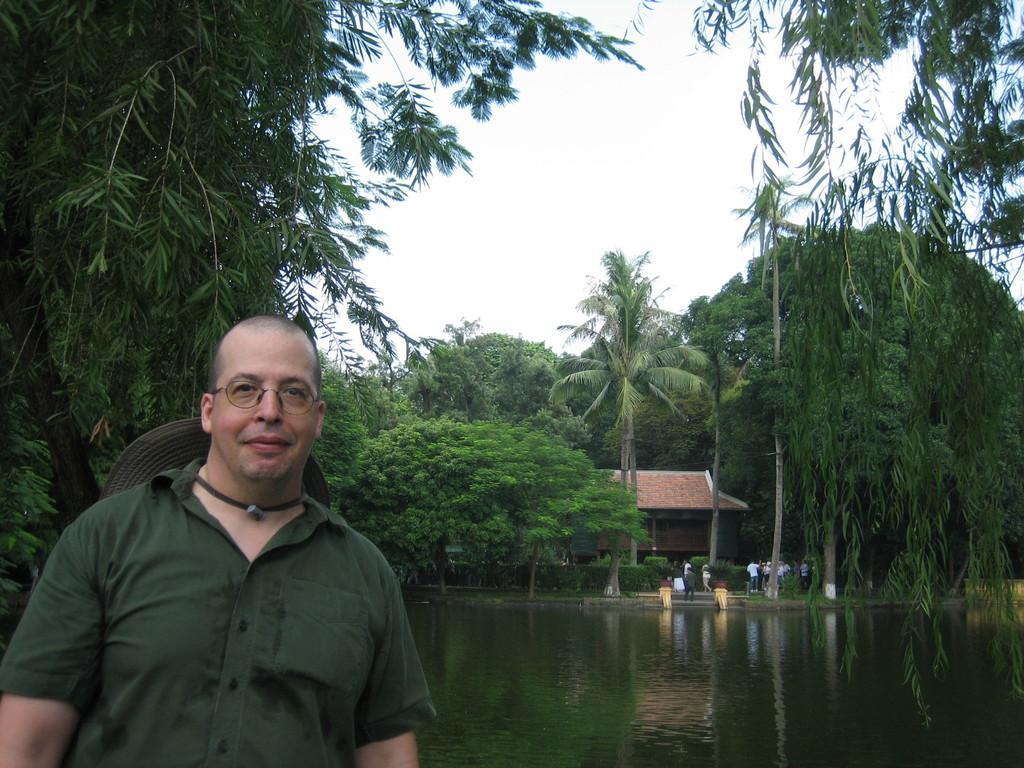In one or two sentences, can you explain what this image depicts? In the image there is a man standing and posing for the photo behind him there is a water surface and around that there are plenty of trees and also a house. 